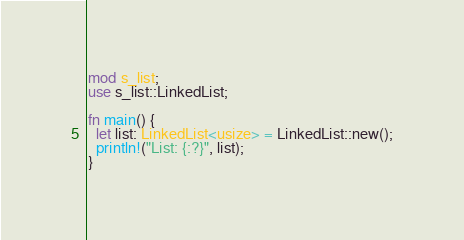<code> <loc_0><loc_0><loc_500><loc_500><_Rust_>mod s_list;
use s_list::LinkedList;

fn main() {
  let list: LinkedList<usize> = LinkedList::new();
  println!("List: {:?}", list);
}
</code> 